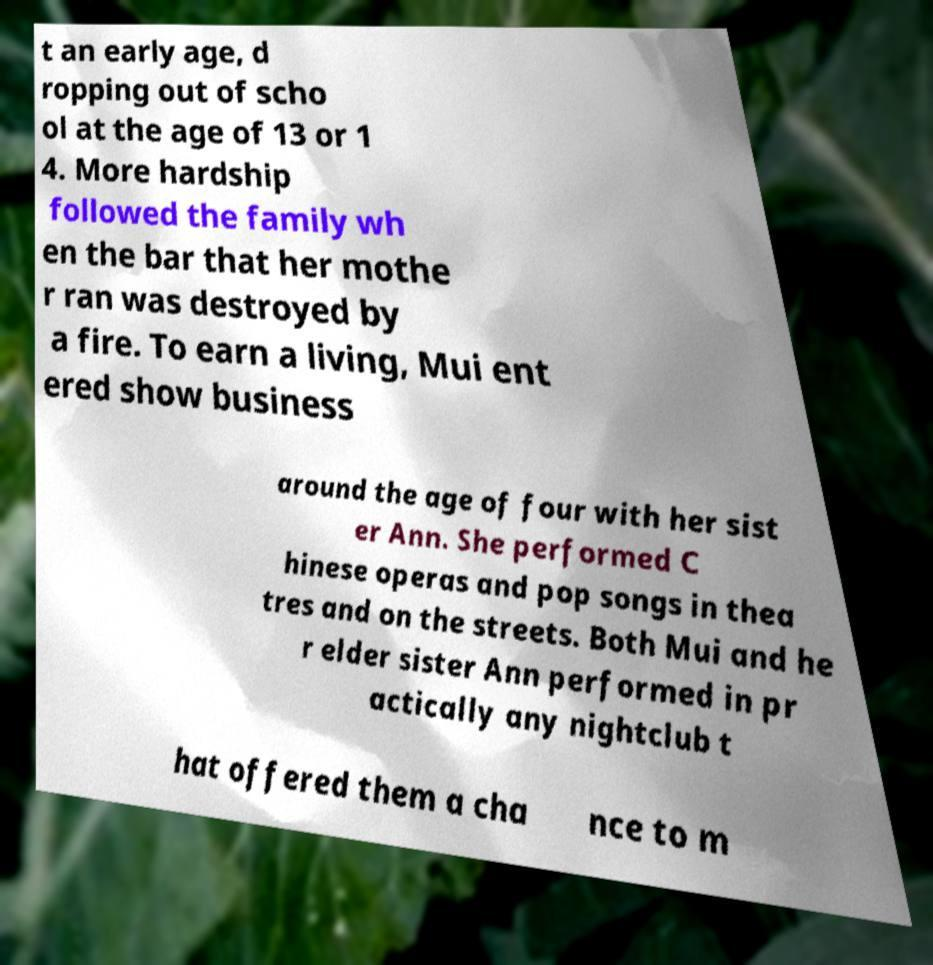Could you assist in decoding the text presented in this image and type it out clearly? t an early age, d ropping out of scho ol at the age of 13 or 1 4. More hardship followed the family wh en the bar that her mothe r ran was destroyed by a fire. To earn a living, Mui ent ered show business around the age of four with her sist er Ann. She performed C hinese operas and pop songs in thea tres and on the streets. Both Mui and he r elder sister Ann performed in pr actically any nightclub t hat offered them a cha nce to m 